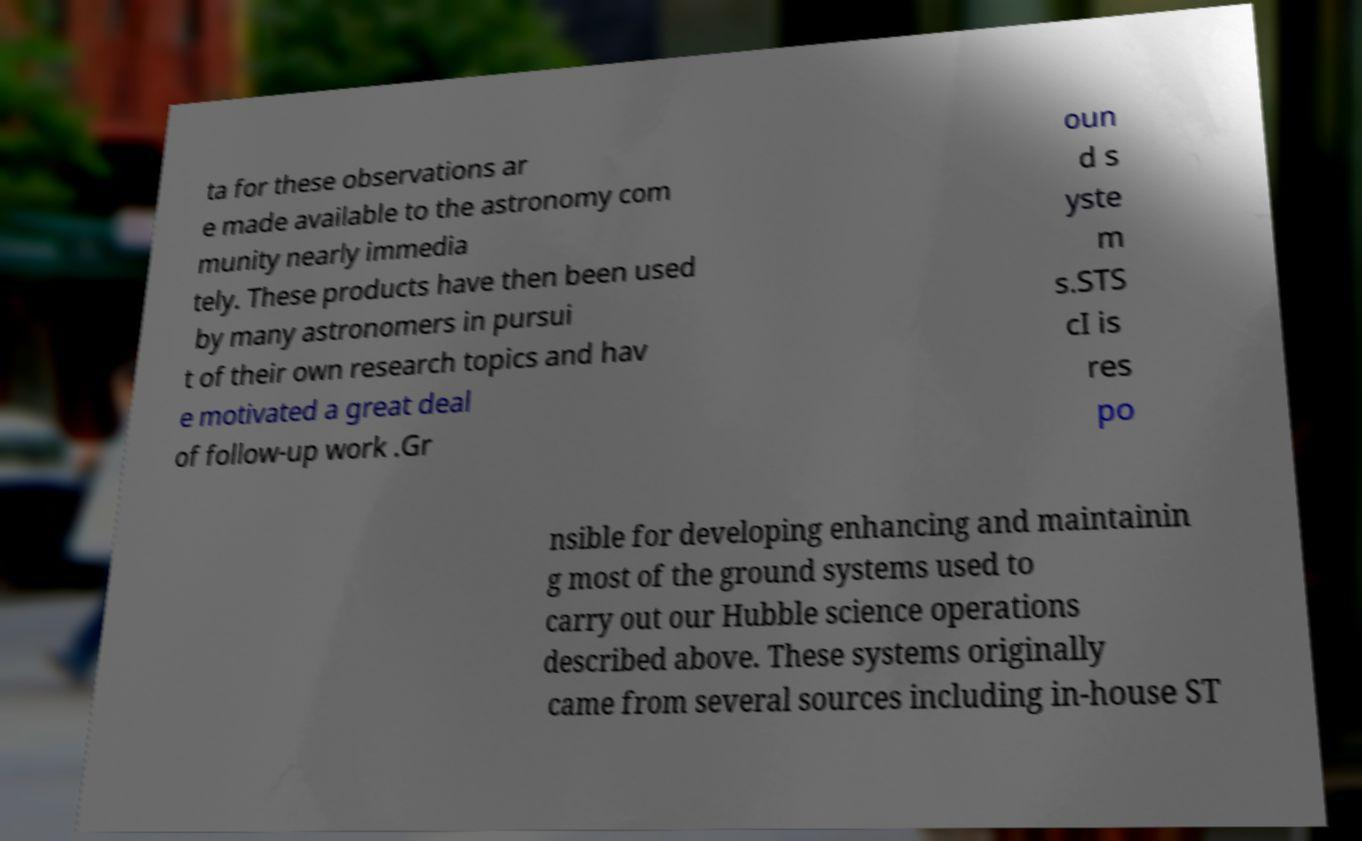There's text embedded in this image that I need extracted. Can you transcribe it verbatim? ta for these observations ar e made available to the astronomy com munity nearly immedia tely. These products have then been used by many astronomers in pursui t of their own research topics and hav e motivated a great deal of follow-up work .Gr oun d s yste m s.STS cI is res po nsible for developing enhancing and maintainin g most of the ground systems used to carry out our Hubble science operations described above. These systems originally came from several sources including in-house ST 